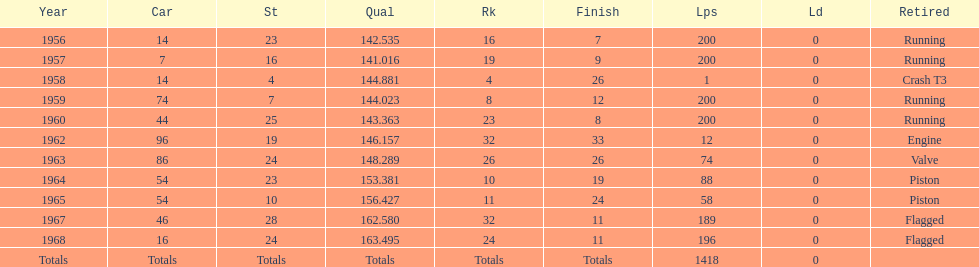How long did bob veith have the number 54 car at the indy 500? 2 years. 